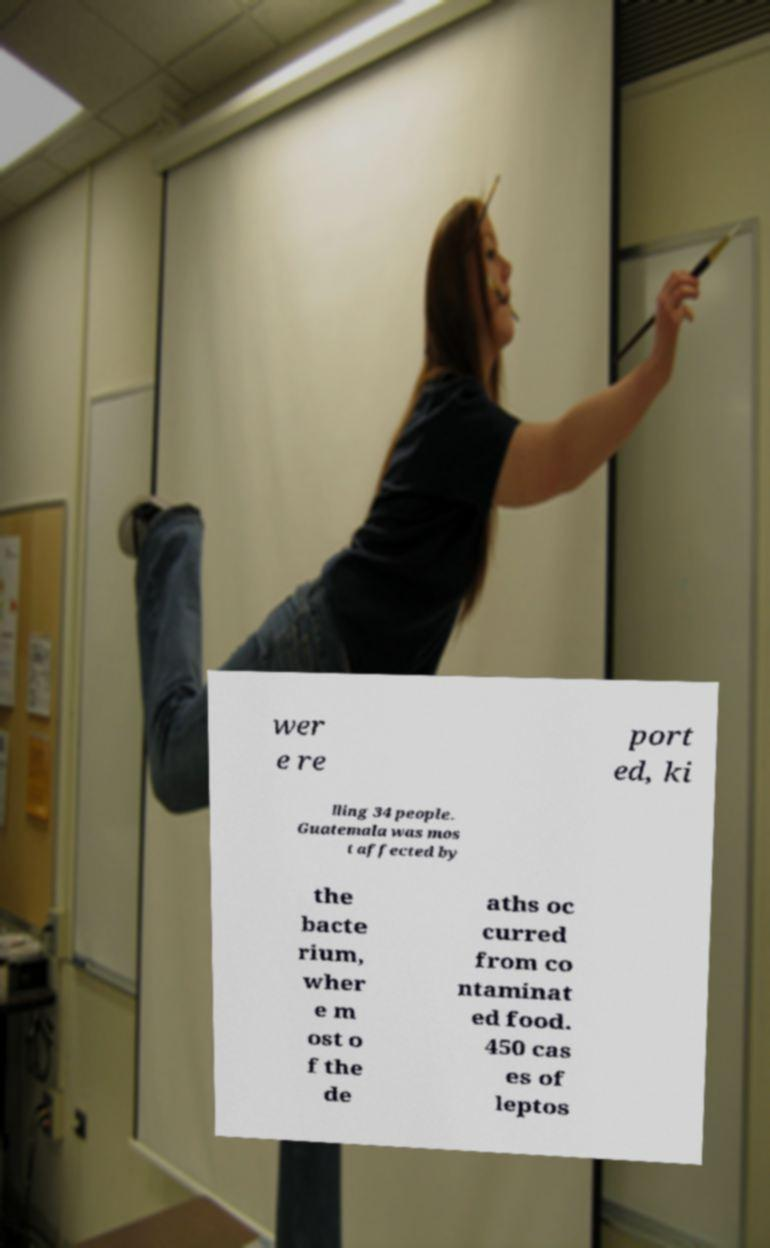There's text embedded in this image that I need extracted. Can you transcribe it verbatim? wer e re port ed, ki lling 34 people. Guatemala was mos t affected by the bacte rium, wher e m ost o f the de aths oc curred from co ntaminat ed food. 450 cas es of leptos 